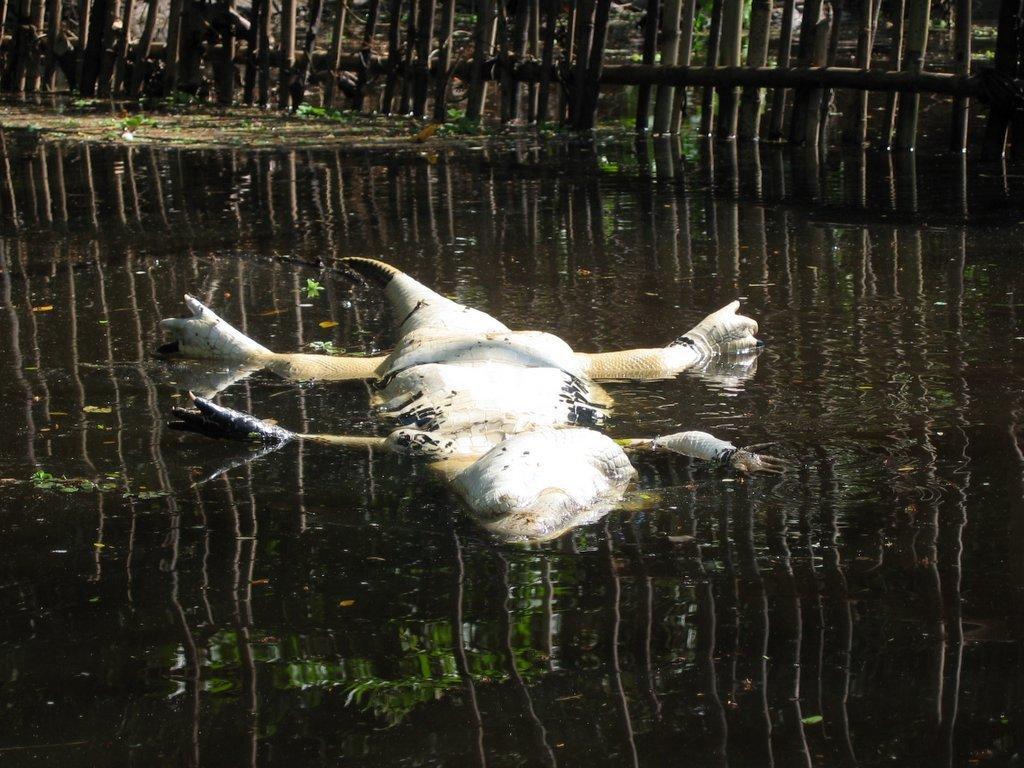In one or two sentences, can you explain what this image depicts? A bird is floating on the water,some reflections which are seen in the water which is of staves. 